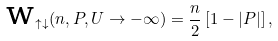Convert formula to latex. <formula><loc_0><loc_0><loc_500><loc_500>\text {w} _ { \uparrow \downarrow } ( n , P , U \rightarrow - \infty ) = \frac { n } { 2 } \left [ 1 - | P | \right ] ,</formula> 